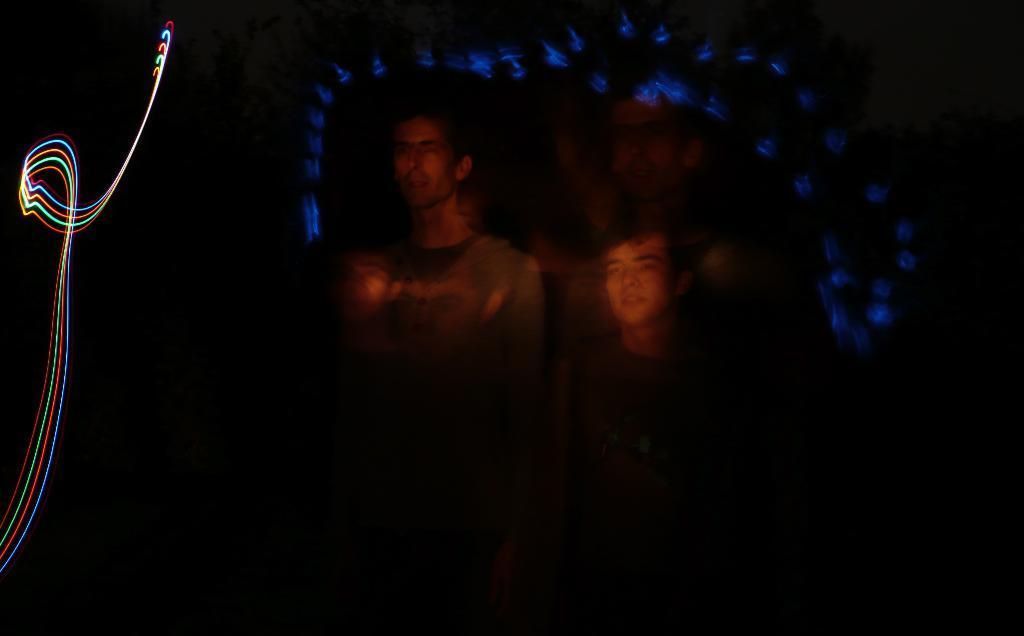How would you summarize this image in a sentence or two? In the center of the image, we can see two people and we can see some lights. 